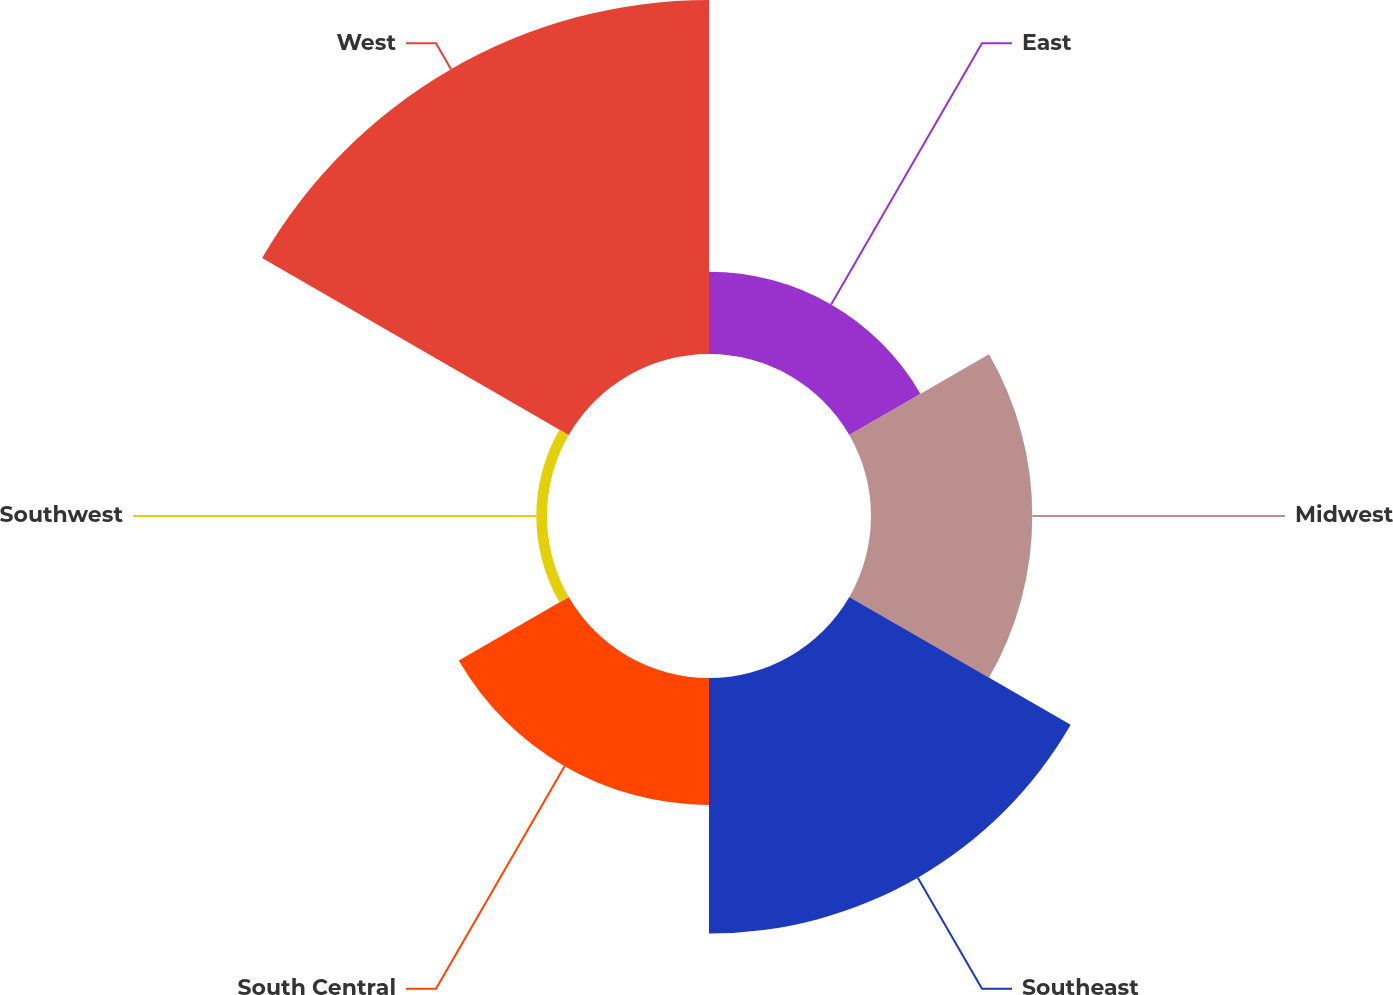<chart> <loc_0><loc_0><loc_500><loc_500><pie_chart><fcel>East<fcel>Midwest<fcel>Southeast<fcel>South Central<fcel>Southwest<fcel>West<nl><fcel>8.3%<fcel>16.28%<fcel>25.8%<fcel>12.81%<fcel>1.08%<fcel>35.73%<nl></chart> 